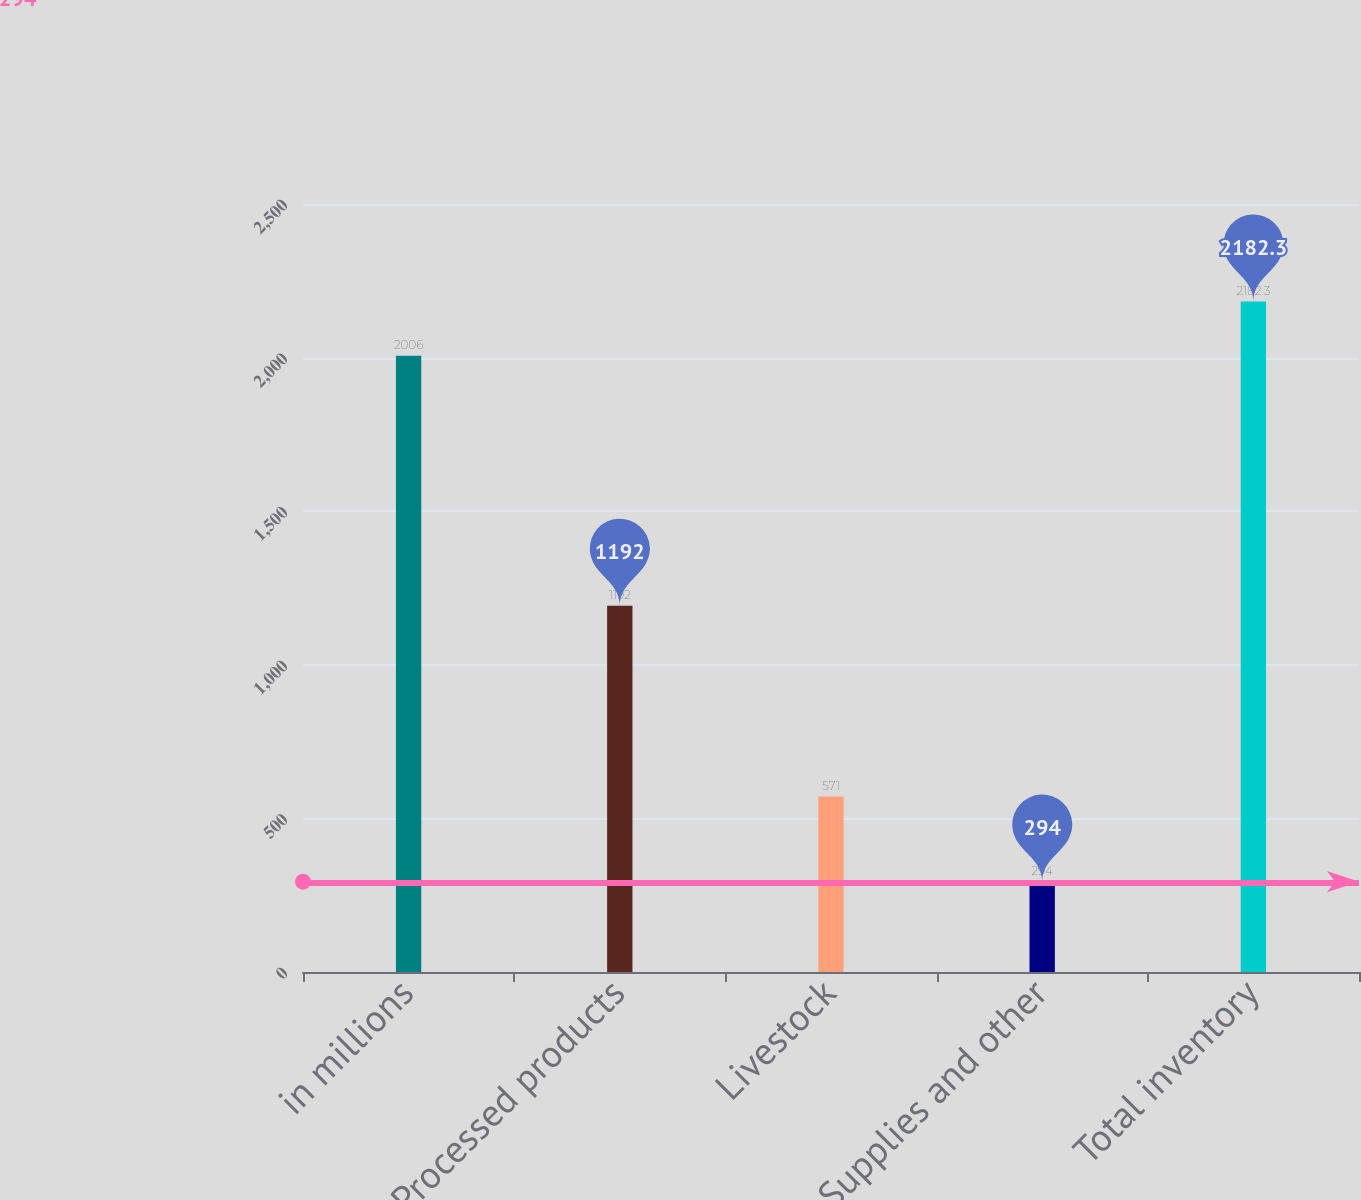<chart> <loc_0><loc_0><loc_500><loc_500><bar_chart><fcel>in millions<fcel>Processed products<fcel>Livestock<fcel>Supplies and other<fcel>Total inventory<nl><fcel>2006<fcel>1192<fcel>571<fcel>294<fcel>2182.3<nl></chart> 